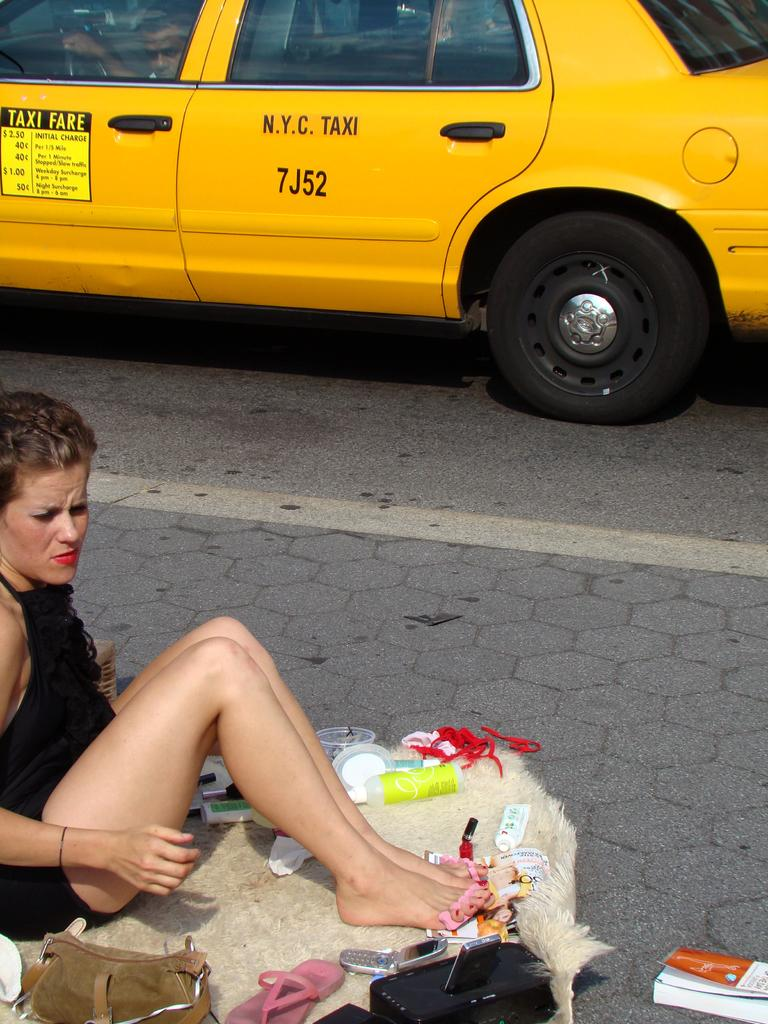<image>
Present a compact description of the photo's key features. Taxi fares are listed on the front driver side door of the cab. 